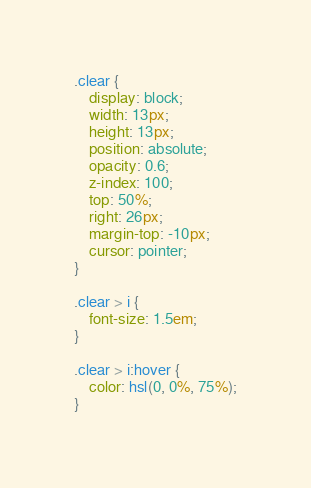Convert code to text. <code><loc_0><loc_0><loc_500><loc_500><_CSS_>.clear {
    display: block;
    width: 13px;
    height: 13px;
    position: absolute;
    opacity: 0.6;
    z-index: 100;
    top: 50%;
    right: 26px;
    margin-top: -10px;
    cursor: pointer;
}

.clear > i {
    font-size: 1.5em;
}

.clear > i:hover {
    color: hsl(0, 0%, 75%);
}</code> 